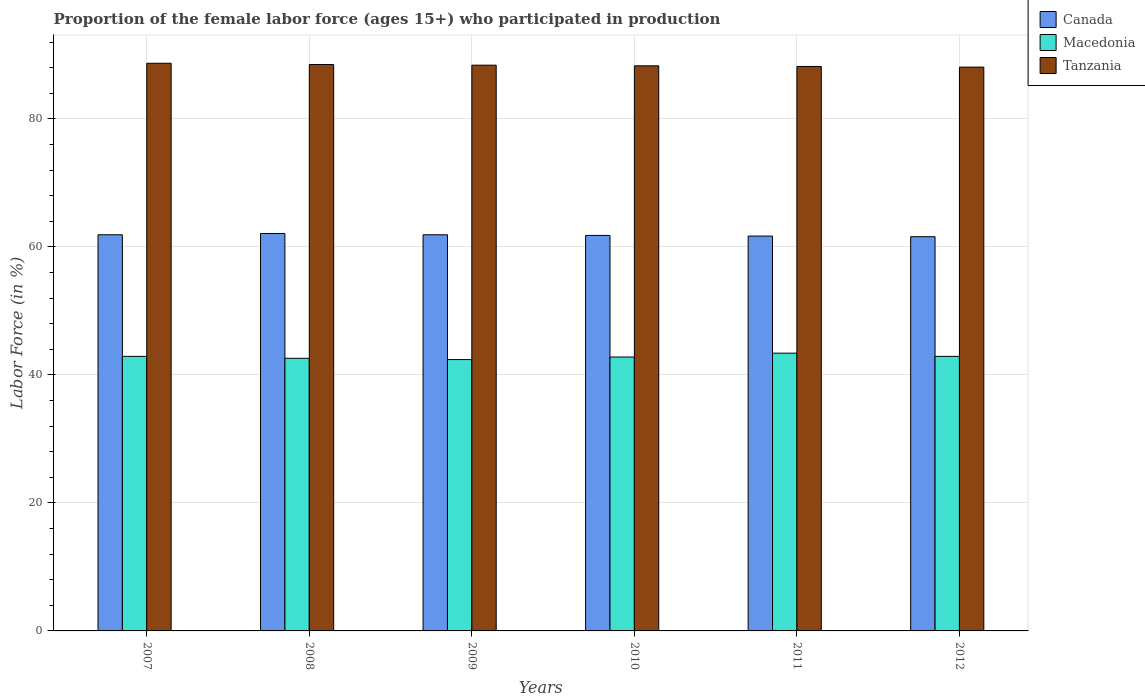How many groups of bars are there?
Offer a very short reply. 6. Are the number of bars per tick equal to the number of legend labels?
Offer a terse response. Yes. Are the number of bars on each tick of the X-axis equal?
Make the answer very short. Yes. How many bars are there on the 1st tick from the right?
Provide a succinct answer. 3. What is the proportion of the female labor force who participated in production in Macedonia in 2009?
Provide a short and direct response. 42.4. Across all years, what is the maximum proportion of the female labor force who participated in production in Canada?
Provide a succinct answer. 62.1. Across all years, what is the minimum proportion of the female labor force who participated in production in Macedonia?
Your answer should be very brief. 42.4. In which year was the proportion of the female labor force who participated in production in Canada maximum?
Offer a very short reply. 2008. What is the total proportion of the female labor force who participated in production in Macedonia in the graph?
Provide a short and direct response. 257. What is the difference between the proportion of the female labor force who participated in production in Tanzania in 2007 and that in 2009?
Your answer should be very brief. 0.3. What is the difference between the proportion of the female labor force who participated in production in Canada in 2008 and the proportion of the female labor force who participated in production in Tanzania in 2009?
Your response must be concise. -26.3. What is the average proportion of the female labor force who participated in production in Macedonia per year?
Your answer should be compact. 42.83. In the year 2012, what is the difference between the proportion of the female labor force who participated in production in Macedonia and proportion of the female labor force who participated in production in Tanzania?
Provide a short and direct response. -45.2. What is the ratio of the proportion of the female labor force who participated in production in Canada in 2008 to that in 2012?
Give a very brief answer. 1.01. Is the proportion of the female labor force who participated in production in Tanzania in 2008 less than that in 2010?
Provide a succinct answer. No. What is the difference between the highest and the second highest proportion of the female labor force who participated in production in Macedonia?
Your answer should be very brief. 0.5. What is the difference between the highest and the lowest proportion of the female labor force who participated in production in Canada?
Provide a succinct answer. 0.5. In how many years, is the proportion of the female labor force who participated in production in Macedonia greater than the average proportion of the female labor force who participated in production in Macedonia taken over all years?
Offer a very short reply. 3. What does the 2nd bar from the left in 2012 represents?
Provide a succinct answer. Macedonia. Is it the case that in every year, the sum of the proportion of the female labor force who participated in production in Macedonia and proportion of the female labor force who participated in production in Tanzania is greater than the proportion of the female labor force who participated in production in Canada?
Offer a very short reply. Yes. How many bars are there?
Keep it short and to the point. 18. What is the difference between two consecutive major ticks on the Y-axis?
Offer a terse response. 20. Does the graph contain grids?
Provide a short and direct response. Yes. Where does the legend appear in the graph?
Offer a very short reply. Top right. What is the title of the graph?
Keep it short and to the point. Proportion of the female labor force (ages 15+) who participated in production. What is the label or title of the Y-axis?
Your answer should be very brief. Labor Force (in %). What is the Labor Force (in %) of Canada in 2007?
Give a very brief answer. 61.9. What is the Labor Force (in %) in Macedonia in 2007?
Provide a succinct answer. 42.9. What is the Labor Force (in %) in Tanzania in 2007?
Provide a succinct answer. 88.7. What is the Labor Force (in %) in Canada in 2008?
Your answer should be compact. 62.1. What is the Labor Force (in %) in Macedonia in 2008?
Your answer should be compact. 42.6. What is the Labor Force (in %) in Tanzania in 2008?
Provide a succinct answer. 88.5. What is the Labor Force (in %) in Canada in 2009?
Ensure brevity in your answer.  61.9. What is the Labor Force (in %) of Macedonia in 2009?
Ensure brevity in your answer.  42.4. What is the Labor Force (in %) in Tanzania in 2009?
Offer a very short reply. 88.4. What is the Labor Force (in %) in Canada in 2010?
Provide a succinct answer. 61.8. What is the Labor Force (in %) of Macedonia in 2010?
Offer a terse response. 42.8. What is the Labor Force (in %) in Tanzania in 2010?
Provide a succinct answer. 88.3. What is the Labor Force (in %) of Canada in 2011?
Make the answer very short. 61.7. What is the Labor Force (in %) in Macedonia in 2011?
Your answer should be compact. 43.4. What is the Labor Force (in %) of Tanzania in 2011?
Your answer should be compact. 88.2. What is the Labor Force (in %) in Canada in 2012?
Give a very brief answer. 61.6. What is the Labor Force (in %) in Macedonia in 2012?
Provide a succinct answer. 42.9. What is the Labor Force (in %) in Tanzania in 2012?
Make the answer very short. 88.1. Across all years, what is the maximum Labor Force (in %) in Canada?
Provide a short and direct response. 62.1. Across all years, what is the maximum Labor Force (in %) of Macedonia?
Keep it short and to the point. 43.4. Across all years, what is the maximum Labor Force (in %) of Tanzania?
Your answer should be very brief. 88.7. Across all years, what is the minimum Labor Force (in %) of Canada?
Offer a terse response. 61.6. Across all years, what is the minimum Labor Force (in %) of Macedonia?
Offer a terse response. 42.4. Across all years, what is the minimum Labor Force (in %) in Tanzania?
Provide a succinct answer. 88.1. What is the total Labor Force (in %) in Canada in the graph?
Provide a succinct answer. 371. What is the total Labor Force (in %) in Macedonia in the graph?
Your answer should be very brief. 257. What is the total Labor Force (in %) of Tanzania in the graph?
Your answer should be very brief. 530.2. What is the difference between the Labor Force (in %) of Macedonia in 2007 and that in 2008?
Ensure brevity in your answer.  0.3. What is the difference between the Labor Force (in %) in Tanzania in 2007 and that in 2009?
Ensure brevity in your answer.  0.3. What is the difference between the Labor Force (in %) of Canada in 2007 and that in 2010?
Your answer should be very brief. 0.1. What is the difference between the Labor Force (in %) of Macedonia in 2007 and that in 2010?
Provide a short and direct response. 0.1. What is the difference between the Labor Force (in %) in Canada in 2007 and that in 2012?
Ensure brevity in your answer.  0.3. What is the difference between the Labor Force (in %) of Tanzania in 2007 and that in 2012?
Your answer should be very brief. 0.6. What is the difference between the Labor Force (in %) of Macedonia in 2008 and that in 2009?
Your answer should be compact. 0.2. What is the difference between the Labor Force (in %) in Tanzania in 2008 and that in 2009?
Your response must be concise. 0.1. What is the difference between the Labor Force (in %) of Canada in 2008 and that in 2010?
Ensure brevity in your answer.  0.3. What is the difference between the Labor Force (in %) of Macedonia in 2008 and that in 2010?
Keep it short and to the point. -0.2. What is the difference between the Labor Force (in %) of Canada in 2008 and that in 2011?
Your answer should be compact. 0.4. What is the difference between the Labor Force (in %) in Macedonia in 2008 and that in 2011?
Your answer should be very brief. -0.8. What is the difference between the Labor Force (in %) in Canada in 2009 and that in 2010?
Keep it short and to the point. 0.1. What is the difference between the Labor Force (in %) in Macedonia in 2009 and that in 2010?
Your answer should be compact. -0.4. What is the difference between the Labor Force (in %) in Tanzania in 2009 and that in 2010?
Your answer should be very brief. 0.1. What is the difference between the Labor Force (in %) of Canada in 2009 and that in 2011?
Your response must be concise. 0.2. What is the difference between the Labor Force (in %) of Macedonia in 2009 and that in 2011?
Ensure brevity in your answer.  -1. What is the difference between the Labor Force (in %) of Tanzania in 2009 and that in 2011?
Make the answer very short. 0.2. What is the difference between the Labor Force (in %) in Canada in 2009 and that in 2012?
Offer a very short reply. 0.3. What is the difference between the Labor Force (in %) in Tanzania in 2009 and that in 2012?
Make the answer very short. 0.3. What is the difference between the Labor Force (in %) of Macedonia in 2010 and that in 2011?
Your response must be concise. -0.6. What is the difference between the Labor Force (in %) of Tanzania in 2010 and that in 2011?
Your answer should be very brief. 0.1. What is the difference between the Labor Force (in %) of Macedonia in 2010 and that in 2012?
Give a very brief answer. -0.1. What is the difference between the Labor Force (in %) of Macedonia in 2011 and that in 2012?
Your answer should be very brief. 0.5. What is the difference between the Labor Force (in %) of Tanzania in 2011 and that in 2012?
Your response must be concise. 0.1. What is the difference between the Labor Force (in %) in Canada in 2007 and the Labor Force (in %) in Macedonia in 2008?
Your response must be concise. 19.3. What is the difference between the Labor Force (in %) in Canada in 2007 and the Labor Force (in %) in Tanzania in 2008?
Your response must be concise. -26.6. What is the difference between the Labor Force (in %) in Macedonia in 2007 and the Labor Force (in %) in Tanzania in 2008?
Your response must be concise. -45.6. What is the difference between the Labor Force (in %) of Canada in 2007 and the Labor Force (in %) of Macedonia in 2009?
Make the answer very short. 19.5. What is the difference between the Labor Force (in %) of Canada in 2007 and the Labor Force (in %) of Tanzania in 2009?
Provide a short and direct response. -26.5. What is the difference between the Labor Force (in %) of Macedonia in 2007 and the Labor Force (in %) of Tanzania in 2009?
Make the answer very short. -45.5. What is the difference between the Labor Force (in %) in Canada in 2007 and the Labor Force (in %) in Tanzania in 2010?
Your response must be concise. -26.4. What is the difference between the Labor Force (in %) of Macedonia in 2007 and the Labor Force (in %) of Tanzania in 2010?
Your answer should be compact. -45.4. What is the difference between the Labor Force (in %) in Canada in 2007 and the Labor Force (in %) in Macedonia in 2011?
Ensure brevity in your answer.  18.5. What is the difference between the Labor Force (in %) in Canada in 2007 and the Labor Force (in %) in Tanzania in 2011?
Your response must be concise. -26.3. What is the difference between the Labor Force (in %) of Macedonia in 2007 and the Labor Force (in %) of Tanzania in 2011?
Give a very brief answer. -45.3. What is the difference between the Labor Force (in %) of Canada in 2007 and the Labor Force (in %) of Tanzania in 2012?
Make the answer very short. -26.2. What is the difference between the Labor Force (in %) in Macedonia in 2007 and the Labor Force (in %) in Tanzania in 2012?
Ensure brevity in your answer.  -45.2. What is the difference between the Labor Force (in %) in Canada in 2008 and the Labor Force (in %) in Macedonia in 2009?
Offer a terse response. 19.7. What is the difference between the Labor Force (in %) of Canada in 2008 and the Labor Force (in %) of Tanzania in 2009?
Make the answer very short. -26.3. What is the difference between the Labor Force (in %) in Macedonia in 2008 and the Labor Force (in %) in Tanzania in 2009?
Provide a succinct answer. -45.8. What is the difference between the Labor Force (in %) of Canada in 2008 and the Labor Force (in %) of Macedonia in 2010?
Your answer should be very brief. 19.3. What is the difference between the Labor Force (in %) in Canada in 2008 and the Labor Force (in %) in Tanzania in 2010?
Your response must be concise. -26.2. What is the difference between the Labor Force (in %) in Macedonia in 2008 and the Labor Force (in %) in Tanzania in 2010?
Ensure brevity in your answer.  -45.7. What is the difference between the Labor Force (in %) in Canada in 2008 and the Labor Force (in %) in Macedonia in 2011?
Make the answer very short. 18.7. What is the difference between the Labor Force (in %) in Canada in 2008 and the Labor Force (in %) in Tanzania in 2011?
Offer a very short reply. -26.1. What is the difference between the Labor Force (in %) of Macedonia in 2008 and the Labor Force (in %) of Tanzania in 2011?
Your response must be concise. -45.6. What is the difference between the Labor Force (in %) of Canada in 2008 and the Labor Force (in %) of Macedonia in 2012?
Provide a succinct answer. 19.2. What is the difference between the Labor Force (in %) of Canada in 2008 and the Labor Force (in %) of Tanzania in 2012?
Provide a short and direct response. -26. What is the difference between the Labor Force (in %) in Macedonia in 2008 and the Labor Force (in %) in Tanzania in 2012?
Give a very brief answer. -45.5. What is the difference between the Labor Force (in %) in Canada in 2009 and the Labor Force (in %) in Macedonia in 2010?
Keep it short and to the point. 19.1. What is the difference between the Labor Force (in %) in Canada in 2009 and the Labor Force (in %) in Tanzania in 2010?
Ensure brevity in your answer.  -26.4. What is the difference between the Labor Force (in %) of Macedonia in 2009 and the Labor Force (in %) of Tanzania in 2010?
Ensure brevity in your answer.  -45.9. What is the difference between the Labor Force (in %) of Canada in 2009 and the Labor Force (in %) of Macedonia in 2011?
Offer a very short reply. 18.5. What is the difference between the Labor Force (in %) in Canada in 2009 and the Labor Force (in %) in Tanzania in 2011?
Your response must be concise. -26.3. What is the difference between the Labor Force (in %) of Macedonia in 2009 and the Labor Force (in %) of Tanzania in 2011?
Keep it short and to the point. -45.8. What is the difference between the Labor Force (in %) in Canada in 2009 and the Labor Force (in %) in Macedonia in 2012?
Make the answer very short. 19. What is the difference between the Labor Force (in %) of Canada in 2009 and the Labor Force (in %) of Tanzania in 2012?
Ensure brevity in your answer.  -26.2. What is the difference between the Labor Force (in %) of Macedonia in 2009 and the Labor Force (in %) of Tanzania in 2012?
Make the answer very short. -45.7. What is the difference between the Labor Force (in %) in Canada in 2010 and the Labor Force (in %) in Tanzania in 2011?
Keep it short and to the point. -26.4. What is the difference between the Labor Force (in %) in Macedonia in 2010 and the Labor Force (in %) in Tanzania in 2011?
Provide a short and direct response. -45.4. What is the difference between the Labor Force (in %) of Canada in 2010 and the Labor Force (in %) of Tanzania in 2012?
Give a very brief answer. -26.3. What is the difference between the Labor Force (in %) in Macedonia in 2010 and the Labor Force (in %) in Tanzania in 2012?
Provide a short and direct response. -45.3. What is the difference between the Labor Force (in %) in Canada in 2011 and the Labor Force (in %) in Tanzania in 2012?
Provide a short and direct response. -26.4. What is the difference between the Labor Force (in %) of Macedonia in 2011 and the Labor Force (in %) of Tanzania in 2012?
Offer a terse response. -44.7. What is the average Labor Force (in %) of Canada per year?
Offer a terse response. 61.83. What is the average Labor Force (in %) of Macedonia per year?
Give a very brief answer. 42.83. What is the average Labor Force (in %) in Tanzania per year?
Offer a terse response. 88.37. In the year 2007, what is the difference between the Labor Force (in %) in Canada and Labor Force (in %) in Tanzania?
Your answer should be compact. -26.8. In the year 2007, what is the difference between the Labor Force (in %) of Macedonia and Labor Force (in %) of Tanzania?
Keep it short and to the point. -45.8. In the year 2008, what is the difference between the Labor Force (in %) of Canada and Labor Force (in %) of Macedonia?
Keep it short and to the point. 19.5. In the year 2008, what is the difference between the Labor Force (in %) of Canada and Labor Force (in %) of Tanzania?
Your answer should be very brief. -26.4. In the year 2008, what is the difference between the Labor Force (in %) in Macedonia and Labor Force (in %) in Tanzania?
Provide a succinct answer. -45.9. In the year 2009, what is the difference between the Labor Force (in %) of Canada and Labor Force (in %) of Tanzania?
Make the answer very short. -26.5. In the year 2009, what is the difference between the Labor Force (in %) of Macedonia and Labor Force (in %) of Tanzania?
Offer a terse response. -46. In the year 2010, what is the difference between the Labor Force (in %) of Canada and Labor Force (in %) of Tanzania?
Keep it short and to the point. -26.5. In the year 2010, what is the difference between the Labor Force (in %) in Macedonia and Labor Force (in %) in Tanzania?
Offer a very short reply. -45.5. In the year 2011, what is the difference between the Labor Force (in %) in Canada and Labor Force (in %) in Macedonia?
Make the answer very short. 18.3. In the year 2011, what is the difference between the Labor Force (in %) of Canada and Labor Force (in %) of Tanzania?
Make the answer very short. -26.5. In the year 2011, what is the difference between the Labor Force (in %) in Macedonia and Labor Force (in %) in Tanzania?
Offer a terse response. -44.8. In the year 2012, what is the difference between the Labor Force (in %) in Canada and Labor Force (in %) in Macedonia?
Your answer should be compact. 18.7. In the year 2012, what is the difference between the Labor Force (in %) in Canada and Labor Force (in %) in Tanzania?
Your response must be concise. -26.5. In the year 2012, what is the difference between the Labor Force (in %) of Macedonia and Labor Force (in %) of Tanzania?
Make the answer very short. -45.2. What is the ratio of the Labor Force (in %) in Macedonia in 2007 to that in 2009?
Give a very brief answer. 1.01. What is the ratio of the Labor Force (in %) in Tanzania in 2007 to that in 2009?
Offer a very short reply. 1. What is the ratio of the Labor Force (in %) of Macedonia in 2007 to that in 2010?
Provide a short and direct response. 1. What is the ratio of the Labor Force (in %) in Tanzania in 2007 to that in 2010?
Give a very brief answer. 1. What is the ratio of the Labor Force (in %) in Canada in 2007 to that in 2011?
Provide a succinct answer. 1. What is the ratio of the Labor Force (in %) in Tanzania in 2007 to that in 2011?
Make the answer very short. 1.01. What is the ratio of the Labor Force (in %) in Canada in 2007 to that in 2012?
Offer a terse response. 1. What is the ratio of the Labor Force (in %) in Macedonia in 2007 to that in 2012?
Offer a very short reply. 1. What is the ratio of the Labor Force (in %) in Tanzania in 2007 to that in 2012?
Offer a very short reply. 1.01. What is the ratio of the Labor Force (in %) in Macedonia in 2008 to that in 2009?
Ensure brevity in your answer.  1. What is the ratio of the Labor Force (in %) of Canada in 2008 to that in 2010?
Provide a short and direct response. 1. What is the ratio of the Labor Force (in %) in Macedonia in 2008 to that in 2010?
Offer a very short reply. 1. What is the ratio of the Labor Force (in %) of Tanzania in 2008 to that in 2010?
Your response must be concise. 1. What is the ratio of the Labor Force (in %) in Macedonia in 2008 to that in 2011?
Give a very brief answer. 0.98. What is the ratio of the Labor Force (in %) of Tanzania in 2008 to that in 2011?
Make the answer very short. 1. What is the ratio of the Labor Force (in %) in Canada in 2008 to that in 2012?
Give a very brief answer. 1.01. What is the ratio of the Labor Force (in %) of Macedonia in 2008 to that in 2012?
Provide a short and direct response. 0.99. What is the ratio of the Labor Force (in %) of Macedonia in 2009 to that in 2010?
Give a very brief answer. 0.99. What is the ratio of the Labor Force (in %) in Canada in 2009 to that in 2011?
Your answer should be very brief. 1. What is the ratio of the Labor Force (in %) in Macedonia in 2009 to that in 2012?
Offer a very short reply. 0.99. What is the ratio of the Labor Force (in %) of Macedonia in 2010 to that in 2011?
Keep it short and to the point. 0.99. What is the ratio of the Labor Force (in %) in Tanzania in 2010 to that in 2011?
Provide a succinct answer. 1. What is the ratio of the Labor Force (in %) of Canada in 2010 to that in 2012?
Keep it short and to the point. 1. What is the ratio of the Labor Force (in %) in Macedonia in 2010 to that in 2012?
Your answer should be compact. 1. What is the ratio of the Labor Force (in %) in Tanzania in 2010 to that in 2012?
Offer a very short reply. 1. What is the ratio of the Labor Force (in %) in Macedonia in 2011 to that in 2012?
Offer a terse response. 1.01. What is the ratio of the Labor Force (in %) in Tanzania in 2011 to that in 2012?
Make the answer very short. 1. What is the difference between the highest and the second highest Labor Force (in %) in Canada?
Your answer should be very brief. 0.2. What is the difference between the highest and the second highest Labor Force (in %) of Macedonia?
Make the answer very short. 0.5. What is the difference between the highest and the second highest Labor Force (in %) of Tanzania?
Provide a succinct answer. 0.2. What is the difference between the highest and the lowest Labor Force (in %) in Canada?
Give a very brief answer. 0.5. 